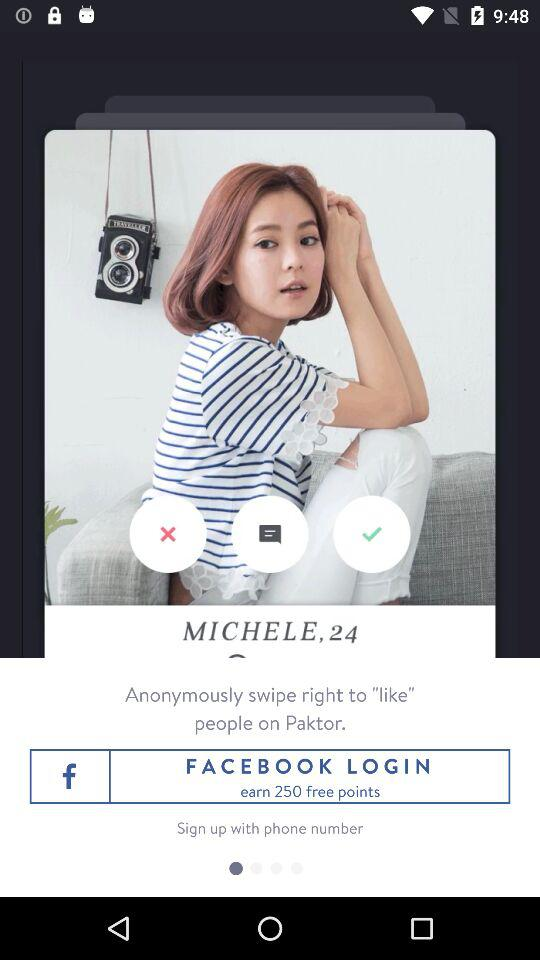What is the user name? The user name is Michele. 